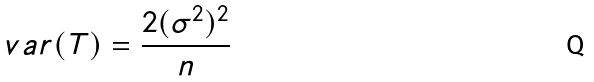<formula> <loc_0><loc_0><loc_500><loc_500>v a r ( T ) = \frac { 2 ( \sigma ^ { 2 } ) ^ { 2 } } { n }</formula> 